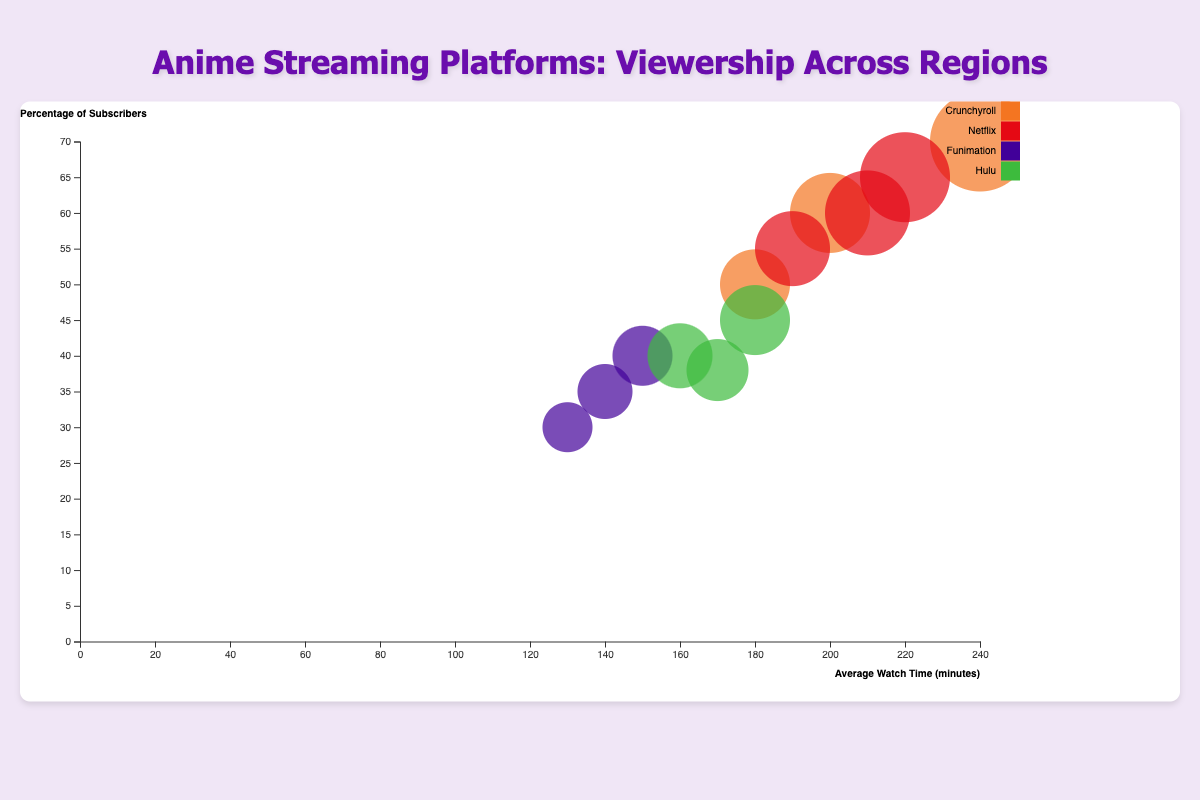How many streaming platforms are represented in the chart? The legend shows different colored boxes representing each streaming platform. Counting these boxes will give the number of platforms.
Answer: 4 Which streaming platform has the highest number of viewers in North America? The bubble chart shows the largest bubble representing the number of viewers in North America. By hovering over the largest bubble in North America, we can see that Crunchyroll has the highest number of viewers.
Answer: Crunchyroll What is the average watch time for Netflix viewers in Asia? We identify the bubble for Netflix in the Asia region by its color (Netflix is red) and label the y-axis (percentage of subscribers). Then, find its x-position and the tooltip shows the average watch time.
Answer: 210 minutes Which region has the highest percentage of subscribers watching Crunchyroll? By comparing the Y-axis positions of the bubbles for Crunchyroll, the highest positioned one corresponds to North America. Hovering over this bubble confirms the percentage.
Answer: North America What is the sum of viewers for Hulu across all regions? Add the number of viewers for Hulu in North America (500,000), Europe (450,000), and Asia (420,000).
Answer: 1,370,000 Which streaming platform has the smallest bubble in Europe, and what does that indicate? The smallest bubble in Europe can be identified visually by color and size. Funimation has the smallest bubble, indicating it has the least number of viewers in Europe.
Answer: Funimation What is the combined percentage of subscribers for Funimation in all regions? Sum the percentage of subscribers for Funimation in North America (40%), Europe (35%), and Asia (30%).
Answer: 105% Compare the average watch times of Crunchyroll and Netflix viewers in Europe. Which is higher and by how much? Find the bubbles for Crunchyroll and Netflix in Europe, refer to their x-axis positions to determine the average watch times (Crunchyroll: 200 minutes, Netflix: 190 minutes). Subtract the lower value from the higher value.
Answer: Crunchyroll by 10 minutes Which streaming platform has a higher percentage of subscribers in Asia: Hulu or Funimation? Look at the y-axis positions of the bubbles for Hulu and Funimation in Asia. Hulu's bubble is higher, indicating a higher percentage of subscribers.
Answer: Hulu What region does the largest bubble represent and which streaming platform does it belong to? Identify the largest bubble on the chart and hover over it to get the details. The tooltip shows it belongs to Crunchyroll in North America with 800,000 viewers.
Answer: North America, Crunchyroll 